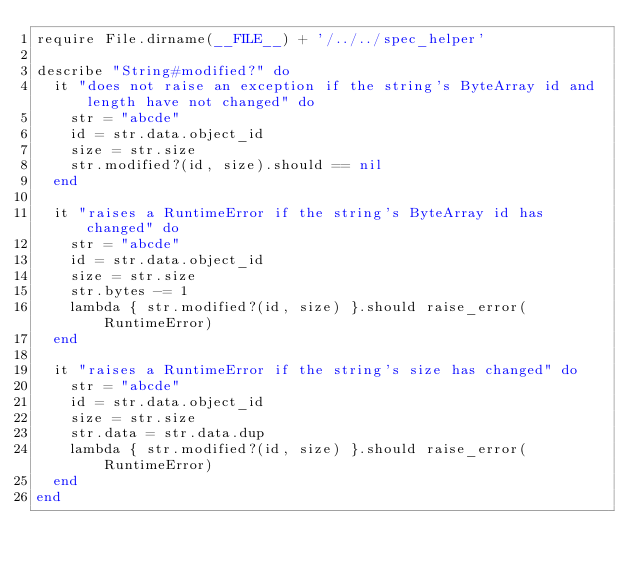Convert code to text. <code><loc_0><loc_0><loc_500><loc_500><_Ruby_>require File.dirname(__FILE__) + '/../../spec_helper'

describe "String#modified?" do
  it "does not raise an exception if the string's ByteArray id and length have not changed" do
    str = "abcde"
    id = str.data.object_id
    size = str.size
    str.modified?(id, size).should == nil
  end

  it "raises a RuntimeError if the string's ByteArray id has changed" do
    str = "abcde"
    id = str.data.object_id
    size = str.size
    str.bytes -= 1
    lambda { str.modified?(id, size) }.should raise_error(RuntimeError)
  end

  it "raises a RuntimeError if the string's size has changed" do
    str = "abcde"
    id = str.data.object_id
    size = str.size
    str.data = str.data.dup
    lambda { str.modified?(id, size) }.should raise_error(RuntimeError)
  end
end
</code> 